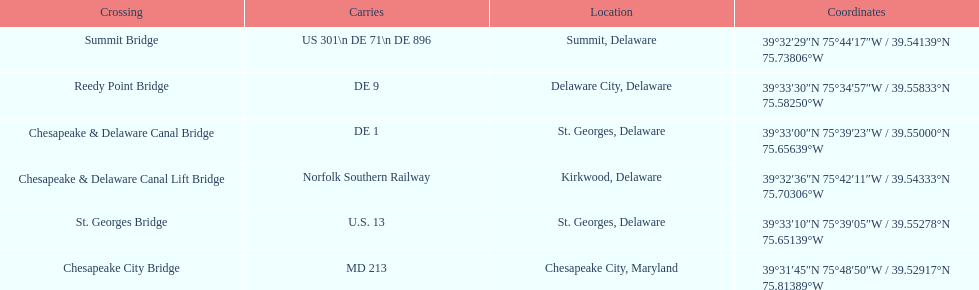Which crossing carries the most routes (e.g., de 1)? Summit Bridge. 